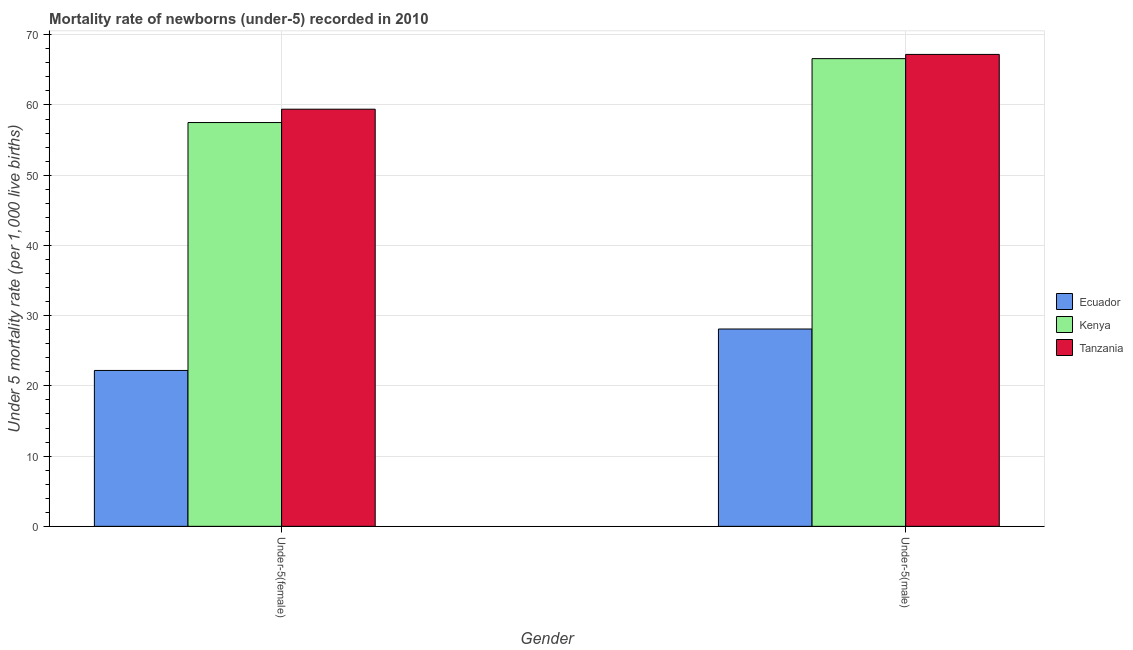How many different coloured bars are there?
Offer a terse response. 3. Are the number of bars per tick equal to the number of legend labels?
Offer a very short reply. Yes. How many bars are there on the 2nd tick from the right?
Make the answer very short. 3. What is the label of the 2nd group of bars from the left?
Your answer should be very brief. Under-5(male). What is the under-5 male mortality rate in Ecuador?
Offer a terse response. 28.1. Across all countries, what is the maximum under-5 male mortality rate?
Your answer should be compact. 67.2. Across all countries, what is the minimum under-5 female mortality rate?
Your response must be concise. 22.2. In which country was the under-5 female mortality rate maximum?
Your response must be concise. Tanzania. In which country was the under-5 female mortality rate minimum?
Make the answer very short. Ecuador. What is the total under-5 female mortality rate in the graph?
Keep it short and to the point. 139.1. What is the difference between the under-5 male mortality rate in Tanzania and that in Kenya?
Give a very brief answer. 0.6. What is the difference between the under-5 female mortality rate in Kenya and the under-5 male mortality rate in Ecuador?
Keep it short and to the point. 29.4. What is the average under-5 female mortality rate per country?
Give a very brief answer. 46.37. What is the difference between the under-5 male mortality rate and under-5 female mortality rate in Tanzania?
Provide a short and direct response. 7.8. In how many countries, is the under-5 female mortality rate greater than 6 ?
Give a very brief answer. 3. What is the ratio of the under-5 female mortality rate in Kenya to that in Tanzania?
Provide a short and direct response. 0.97. Is the under-5 male mortality rate in Kenya less than that in Tanzania?
Ensure brevity in your answer.  Yes. What does the 3rd bar from the left in Under-5(female) represents?
Make the answer very short. Tanzania. What does the 1st bar from the right in Under-5(female) represents?
Your answer should be very brief. Tanzania. How many bars are there?
Ensure brevity in your answer.  6. How many countries are there in the graph?
Your response must be concise. 3. What is the difference between two consecutive major ticks on the Y-axis?
Your answer should be very brief. 10. Are the values on the major ticks of Y-axis written in scientific E-notation?
Your response must be concise. No. Does the graph contain grids?
Provide a succinct answer. Yes. Where does the legend appear in the graph?
Offer a very short reply. Center right. How many legend labels are there?
Provide a succinct answer. 3. How are the legend labels stacked?
Your answer should be very brief. Vertical. What is the title of the graph?
Offer a terse response. Mortality rate of newborns (under-5) recorded in 2010. Does "Cabo Verde" appear as one of the legend labels in the graph?
Your answer should be compact. No. What is the label or title of the X-axis?
Provide a short and direct response. Gender. What is the label or title of the Y-axis?
Ensure brevity in your answer.  Under 5 mortality rate (per 1,0 live births). What is the Under 5 mortality rate (per 1,000 live births) in Kenya in Under-5(female)?
Keep it short and to the point. 57.5. What is the Under 5 mortality rate (per 1,000 live births) in Tanzania in Under-5(female)?
Keep it short and to the point. 59.4. What is the Under 5 mortality rate (per 1,000 live births) in Ecuador in Under-5(male)?
Offer a very short reply. 28.1. What is the Under 5 mortality rate (per 1,000 live births) of Kenya in Under-5(male)?
Make the answer very short. 66.6. What is the Under 5 mortality rate (per 1,000 live births) of Tanzania in Under-5(male)?
Offer a very short reply. 67.2. Across all Gender, what is the maximum Under 5 mortality rate (per 1,000 live births) of Ecuador?
Make the answer very short. 28.1. Across all Gender, what is the maximum Under 5 mortality rate (per 1,000 live births) in Kenya?
Keep it short and to the point. 66.6. Across all Gender, what is the maximum Under 5 mortality rate (per 1,000 live births) in Tanzania?
Offer a very short reply. 67.2. Across all Gender, what is the minimum Under 5 mortality rate (per 1,000 live births) in Kenya?
Your answer should be compact. 57.5. Across all Gender, what is the minimum Under 5 mortality rate (per 1,000 live births) in Tanzania?
Your answer should be very brief. 59.4. What is the total Under 5 mortality rate (per 1,000 live births) of Ecuador in the graph?
Make the answer very short. 50.3. What is the total Under 5 mortality rate (per 1,000 live births) of Kenya in the graph?
Ensure brevity in your answer.  124.1. What is the total Under 5 mortality rate (per 1,000 live births) of Tanzania in the graph?
Make the answer very short. 126.6. What is the difference between the Under 5 mortality rate (per 1,000 live births) of Ecuador in Under-5(female) and that in Under-5(male)?
Your answer should be compact. -5.9. What is the difference between the Under 5 mortality rate (per 1,000 live births) of Tanzania in Under-5(female) and that in Under-5(male)?
Make the answer very short. -7.8. What is the difference between the Under 5 mortality rate (per 1,000 live births) in Ecuador in Under-5(female) and the Under 5 mortality rate (per 1,000 live births) in Kenya in Under-5(male)?
Ensure brevity in your answer.  -44.4. What is the difference between the Under 5 mortality rate (per 1,000 live births) in Ecuador in Under-5(female) and the Under 5 mortality rate (per 1,000 live births) in Tanzania in Under-5(male)?
Ensure brevity in your answer.  -45. What is the average Under 5 mortality rate (per 1,000 live births) in Ecuador per Gender?
Your answer should be very brief. 25.15. What is the average Under 5 mortality rate (per 1,000 live births) in Kenya per Gender?
Make the answer very short. 62.05. What is the average Under 5 mortality rate (per 1,000 live births) of Tanzania per Gender?
Keep it short and to the point. 63.3. What is the difference between the Under 5 mortality rate (per 1,000 live births) of Ecuador and Under 5 mortality rate (per 1,000 live births) of Kenya in Under-5(female)?
Your response must be concise. -35.3. What is the difference between the Under 5 mortality rate (per 1,000 live births) of Ecuador and Under 5 mortality rate (per 1,000 live births) of Tanzania in Under-5(female)?
Give a very brief answer. -37.2. What is the difference between the Under 5 mortality rate (per 1,000 live births) of Kenya and Under 5 mortality rate (per 1,000 live births) of Tanzania in Under-5(female)?
Your answer should be compact. -1.9. What is the difference between the Under 5 mortality rate (per 1,000 live births) in Ecuador and Under 5 mortality rate (per 1,000 live births) in Kenya in Under-5(male)?
Your answer should be compact. -38.5. What is the difference between the Under 5 mortality rate (per 1,000 live births) in Ecuador and Under 5 mortality rate (per 1,000 live births) in Tanzania in Under-5(male)?
Offer a terse response. -39.1. What is the ratio of the Under 5 mortality rate (per 1,000 live births) in Ecuador in Under-5(female) to that in Under-5(male)?
Ensure brevity in your answer.  0.79. What is the ratio of the Under 5 mortality rate (per 1,000 live births) in Kenya in Under-5(female) to that in Under-5(male)?
Make the answer very short. 0.86. What is the ratio of the Under 5 mortality rate (per 1,000 live births) of Tanzania in Under-5(female) to that in Under-5(male)?
Offer a terse response. 0.88. What is the difference between the highest and the second highest Under 5 mortality rate (per 1,000 live births) of Kenya?
Provide a short and direct response. 9.1. 